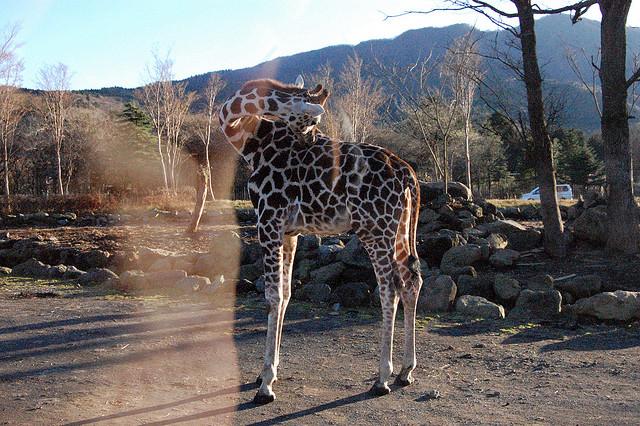Sunny or overcast?
Give a very brief answer. Sunny. Is the animal itchy?
Short answer required. Yes. Are the boulders large?
Be succinct. No. Is it raining?
Answer briefly. No. 